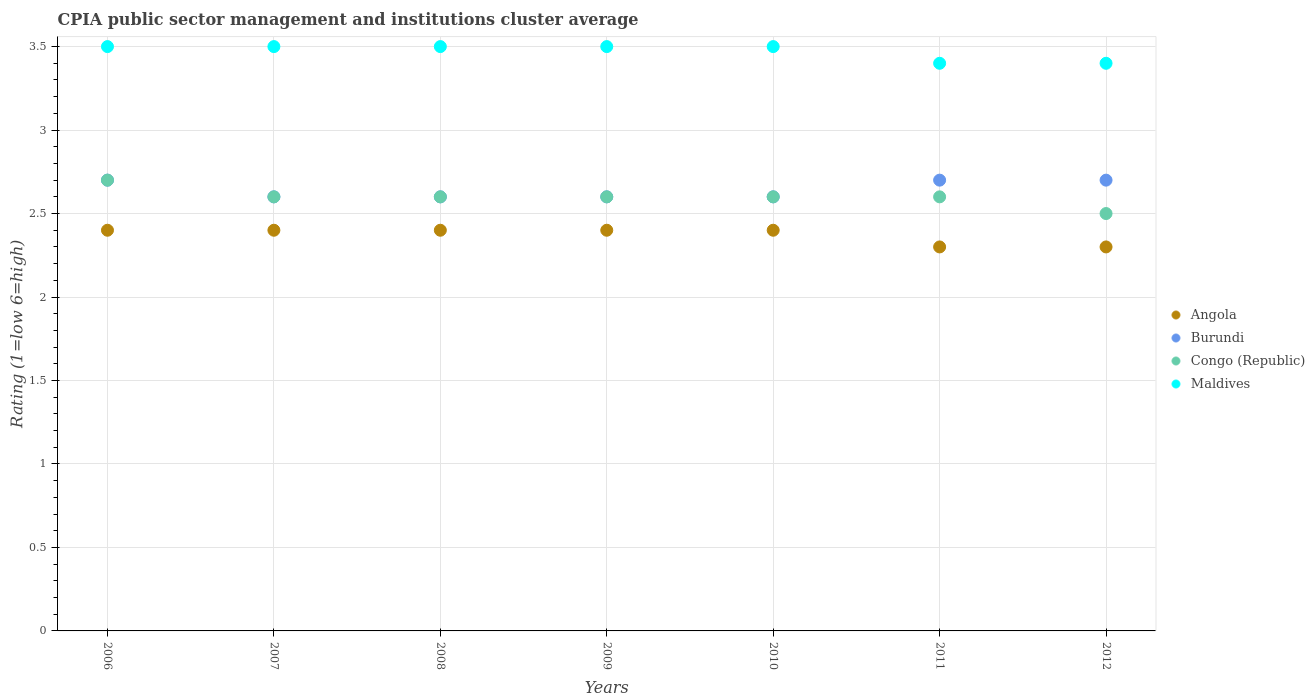Is the number of dotlines equal to the number of legend labels?
Give a very brief answer. Yes. What is the CPIA rating in Maldives in 2010?
Keep it short and to the point. 3.5. Across all years, what is the maximum CPIA rating in Angola?
Your response must be concise. 2.4. Across all years, what is the minimum CPIA rating in Angola?
Provide a succinct answer. 2.3. In which year was the CPIA rating in Burundi maximum?
Keep it short and to the point. 2006. What is the difference between the CPIA rating in Burundi in 2010 and that in 2011?
Your answer should be compact. -0.1. What is the difference between the CPIA rating in Maldives in 2009 and the CPIA rating in Angola in 2007?
Give a very brief answer. 1.1. What is the average CPIA rating in Maldives per year?
Provide a succinct answer. 3.47. In the year 2007, what is the difference between the CPIA rating in Burundi and CPIA rating in Maldives?
Give a very brief answer. -0.9. In how many years, is the CPIA rating in Angola greater than 1.5?
Your response must be concise. 7. What is the ratio of the CPIA rating in Angola in 2007 to that in 2009?
Your answer should be compact. 1. What is the difference between the highest and the lowest CPIA rating in Congo (Republic)?
Offer a terse response. 0.2. Is it the case that in every year, the sum of the CPIA rating in Congo (Republic) and CPIA rating in Burundi  is greater than the sum of CPIA rating in Maldives and CPIA rating in Angola?
Provide a short and direct response. No. Does the CPIA rating in Burundi monotonically increase over the years?
Ensure brevity in your answer.  No. Are the values on the major ticks of Y-axis written in scientific E-notation?
Make the answer very short. No. Does the graph contain grids?
Your answer should be very brief. Yes. What is the title of the graph?
Give a very brief answer. CPIA public sector management and institutions cluster average. What is the label or title of the Y-axis?
Provide a succinct answer. Rating (1=low 6=high). What is the Rating (1=low 6=high) of Angola in 2006?
Provide a short and direct response. 2.4. What is the Rating (1=low 6=high) of Burundi in 2006?
Your answer should be very brief. 2.7. What is the Rating (1=low 6=high) in Maldives in 2006?
Offer a very short reply. 3.5. What is the Rating (1=low 6=high) in Burundi in 2007?
Provide a short and direct response. 2.6. What is the Rating (1=low 6=high) in Congo (Republic) in 2007?
Make the answer very short. 2.6. What is the Rating (1=low 6=high) of Maldives in 2007?
Provide a short and direct response. 3.5. What is the Rating (1=low 6=high) of Angola in 2008?
Provide a succinct answer. 2.4. What is the Rating (1=low 6=high) in Burundi in 2008?
Ensure brevity in your answer.  2.6. What is the Rating (1=low 6=high) in Congo (Republic) in 2008?
Your answer should be very brief. 2.6. What is the Rating (1=low 6=high) in Maldives in 2008?
Provide a succinct answer. 3.5. What is the Rating (1=low 6=high) of Angola in 2010?
Ensure brevity in your answer.  2.4. What is the Rating (1=low 6=high) of Maldives in 2010?
Keep it short and to the point. 3.5. What is the Rating (1=low 6=high) of Burundi in 2011?
Provide a short and direct response. 2.7. What is the Rating (1=low 6=high) of Congo (Republic) in 2011?
Your response must be concise. 2.6. What is the Rating (1=low 6=high) in Angola in 2012?
Ensure brevity in your answer.  2.3. What is the Rating (1=low 6=high) in Congo (Republic) in 2012?
Your response must be concise. 2.5. Across all years, what is the maximum Rating (1=low 6=high) of Angola?
Ensure brevity in your answer.  2.4. Across all years, what is the maximum Rating (1=low 6=high) of Congo (Republic)?
Keep it short and to the point. 2.7. Across all years, what is the maximum Rating (1=low 6=high) in Maldives?
Your answer should be compact. 3.5. Across all years, what is the minimum Rating (1=low 6=high) of Congo (Republic)?
Offer a very short reply. 2.5. What is the total Rating (1=low 6=high) of Angola in the graph?
Ensure brevity in your answer.  16.6. What is the total Rating (1=low 6=high) in Burundi in the graph?
Your answer should be very brief. 18.5. What is the total Rating (1=low 6=high) in Congo (Republic) in the graph?
Your answer should be compact. 18.2. What is the total Rating (1=low 6=high) in Maldives in the graph?
Your answer should be very brief. 24.3. What is the difference between the Rating (1=low 6=high) of Burundi in 2006 and that in 2007?
Ensure brevity in your answer.  0.1. What is the difference between the Rating (1=low 6=high) of Angola in 2006 and that in 2008?
Make the answer very short. 0. What is the difference between the Rating (1=low 6=high) of Maldives in 2006 and that in 2008?
Offer a terse response. 0. What is the difference between the Rating (1=low 6=high) in Burundi in 2006 and that in 2009?
Your answer should be compact. 0.1. What is the difference between the Rating (1=low 6=high) of Maldives in 2006 and that in 2009?
Your response must be concise. 0. What is the difference between the Rating (1=low 6=high) of Burundi in 2006 and that in 2010?
Provide a short and direct response. 0.1. What is the difference between the Rating (1=low 6=high) of Angola in 2006 and that in 2011?
Your answer should be very brief. 0.1. What is the difference between the Rating (1=low 6=high) in Angola in 2006 and that in 2012?
Make the answer very short. 0.1. What is the difference between the Rating (1=low 6=high) of Congo (Republic) in 2006 and that in 2012?
Keep it short and to the point. 0.2. What is the difference between the Rating (1=low 6=high) in Maldives in 2006 and that in 2012?
Ensure brevity in your answer.  0.1. What is the difference between the Rating (1=low 6=high) of Angola in 2007 and that in 2008?
Offer a very short reply. 0. What is the difference between the Rating (1=low 6=high) of Burundi in 2007 and that in 2008?
Your answer should be very brief. 0. What is the difference between the Rating (1=low 6=high) of Congo (Republic) in 2007 and that in 2008?
Provide a short and direct response. 0. What is the difference between the Rating (1=low 6=high) of Burundi in 2007 and that in 2009?
Make the answer very short. 0. What is the difference between the Rating (1=low 6=high) in Burundi in 2007 and that in 2010?
Your answer should be compact. 0. What is the difference between the Rating (1=low 6=high) of Congo (Republic) in 2007 and that in 2010?
Provide a succinct answer. 0. What is the difference between the Rating (1=low 6=high) in Maldives in 2007 and that in 2010?
Offer a terse response. 0. What is the difference between the Rating (1=low 6=high) of Congo (Republic) in 2007 and that in 2011?
Your answer should be very brief. 0. What is the difference between the Rating (1=low 6=high) of Maldives in 2007 and that in 2011?
Your answer should be very brief. 0.1. What is the difference between the Rating (1=low 6=high) in Angola in 2007 and that in 2012?
Offer a very short reply. 0.1. What is the difference between the Rating (1=low 6=high) of Burundi in 2007 and that in 2012?
Your answer should be compact. -0.1. What is the difference between the Rating (1=low 6=high) in Congo (Republic) in 2008 and that in 2009?
Keep it short and to the point. 0. What is the difference between the Rating (1=low 6=high) in Angola in 2008 and that in 2010?
Ensure brevity in your answer.  0. What is the difference between the Rating (1=low 6=high) of Congo (Republic) in 2008 and that in 2010?
Make the answer very short. 0. What is the difference between the Rating (1=low 6=high) in Angola in 2008 and that in 2011?
Your answer should be compact. 0.1. What is the difference between the Rating (1=low 6=high) in Burundi in 2008 and that in 2012?
Keep it short and to the point. -0.1. What is the difference between the Rating (1=low 6=high) of Congo (Republic) in 2008 and that in 2012?
Your answer should be compact. 0.1. What is the difference between the Rating (1=low 6=high) of Angola in 2009 and that in 2011?
Provide a short and direct response. 0.1. What is the difference between the Rating (1=low 6=high) in Congo (Republic) in 2009 and that in 2011?
Keep it short and to the point. 0. What is the difference between the Rating (1=low 6=high) of Maldives in 2009 and that in 2011?
Give a very brief answer. 0.1. What is the difference between the Rating (1=low 6=high) of Angola in 2009 and that in 2012?
Provide a short and direct response. 0.1. What is the difference between the Rating (1=low 6=high) in Angola in 2010 and that in 2011?
Ensure brevity in your answer.  0.1. What is the difference between the Rating (1=low 6=high) of Burundi in 2010 and that in 2011?
Your answer should be very brief. -0.1. What is the difference between the Rating (1=low 6=high) of Congo (Republic) in 2010 and that in 2011?
Make the answer very short. 0. What is the difference between the Rating (1=low 6=high) of Maldives in 2010 and that in 2011?
Your response must be concise. 0.1. What is the difference between the Rating (1=low 6=high) of Angola in 2010 and that in 2012?
Give a very brief answer. 0.1. What is the difference between the Rating (1=low 6=high) in Burundi in 2010 and that in 2012?
Make the answer very short. -0.1. What is the difference between the Rating (1=low 6=high) in Congo (Republic) in 2010 and that in 2012?
Make the answer very short. 0.1. What is the difference between the Rating (1=low 6=high) of Angola in 2011 and that in 2012?
Provide a succinct answer. 0. What is the difference between the Rating (1=low 6=high) of Maldives in 2011 and that in 2012?
Your response must be concise. 0. What is the difference between the Rating (1=low 6=high) of Angola in 2006 and the Rating (1=low 6=high) of Congo (Republic) in 2007?
Give a very brief answer. -0.2. What is the difference between the Rating (1=low 6=high) of Burundi in 2006 and the Rating (1=low 6=high) of Maldives in 2007?
Your answer should be compact. -0.8. What is the difference between the Rating (1=low 6=high) of Congo (Republic) in 2006 and the Rating (1=low 6=high) of Maldives in 2007?
Keep it short and to the point. -0.8. What is the difference between the Rating (1=low 6=high) of Angola in 2006 and the Rating (1=low 6=high) of Maldives in 2008?
Your answer should be very brief. -1.1. What is the difference between the Rating (1=low 6=high) of Burundi in 2006 and the Rating (1=low 6=high) of Maldives in 2008?
Provide a short and direct response. -0.8. What is the difference between the Rating (1=low 6=high) in Angola in 2006 and the Rating (1=low 6=high) in Burundi in 2009?
Your response must be concise. -0.2. What is the difference between the Rating (1=low 6=high) in Burundi in 2006 and the Rating (1=low 6=high) in Congo (Republic) in 2009?
Make the answer very short. 0.1. What is the difference between the Rating (1=low 6=high) of Angola in 2006 and the Rating (1=low 6=high) of Burundi in 2010?
Give a very brief answer. -0.2. What is the difference between the Rating (1=low 6=high) in Burundi in 2006 and the Rating (1=low 6=high) in Maldives in 2010?
Your response must be concise. -0.8. What is the difference between the Rating (1=low 6=high) of Congo (Republic) in 2006 and the Rating (1=low 6=high) of Maldives in 2010?
Keep it short and to the point. -0.8. What is the difference between the Rating (1=low 6=high) of Angola in 2006 and the Rating (1=low 6=high) of Burundi in 2011?
Give a very brief answer. -0.3. What is the difference between the Rating (1=low 6=high) of Angola in 2006 and the Rating (1=low 6=high) of Congo (Republic) in 2011?
Offer a terse response. -0.2. What is the difference between the Rating (1=low 6=high) in Angola in 2006 and the Rating (1=low 6=high) in Maldives in 2011?
Your answer should be very brief. -1. What is the difference between the Rating (1=low 6=high) of Burundi in 2006 and the Rating (1=low 6=high) of Congo (Republic) in 2011?
Ensure brevity in your answer.  0.1. What is the difference between the Rating (1=low 6=high) in Angola in 2006 and the Rating (1=low 6=high) in Burundi in 2012?
Your answer should be very brief. -0.3. What is the difference between the Rating (1=low 6=high) in Angola in 2006 and the Rating (1=low 6=high) in Maldives in 2012?
Give a very brief answer. -1. What is the difference between the Rating (1=low 6=high) in Burundi in 2006 and the Rating (1=low 6=high) in Maldives in 2012?
Provide a succinct answer. -0.7. What is the difference between the Rating (1=low 6=high) of Burundi in 2007 and the Rating (1=low 6=high) of Congo (Republic) in 2008?
Offer a terse response. 0. What is the difference between the Rating (1=low 6=high) in Angola in 2007 and the Rating (1=low 6=high) in Maldives in 2009?
Make the answer very short. -1.1. What is the difference between the Rating (1=low 6=high) in Burundi in 2007 and the Rating (1=low 6=high) in Maldives in 2009?
Ensure brevity in your answer.  -0.9. What is the difference between the Rating (1=low 6=high) in Congo (Republic) in 2007 and the Rating (1=low 6=high) in Maldives in 2009?
Make the answer very short. -0.9. What is the difference between the Rating (1=low 6=high) in Angola in 2007 and the Rating (1=low 6=high) in Burundi in 2010?
Your answer should be very brief. -0.2. What is the difference between the Rating (1=low 6=high) of Angola in 2007 and the Rating (1=low 6=high) of Congo (Republic) in 2010?
Ensure brevity in your answer.  -0.2. What is the difference between the Rating (1=low 6=high) of Angola in 2007 and the Rating (1=low 6=high) of Congo (Republic) in 2011?
Provide a short and direct response. -0.2. What is the difference between the Rating (1=low 6=high) in Angola in 2007 and the Rating (1=low 6=high) in Maldives in 2011?
Give a very brief answer. -1. What is the difference between the Rating (1=low 6=high) of Burundi in 2007 and the Rating (1=low 6=high) of Maldives in 2011?
Provide a short and direct response. -0.8. What is the difference between the Rating (1=low 6=high) in Congo (Republic) in 2007 and the Rating (1=low 6=high) in Maldives in 2011?
Provide a short and direct response. -0.8. What is the difference between the Rating (1=low 6=high) in Angola in 2007 and the Rating (1=low 6=high) in Burundi in 2012?
Your answer should be very brief. -0.3. What is the difference between the Rating (1=low 6=high) of Angola in 2007 and the Rating (1=low 6=high) of Congo (Republic) in 2012?
Offer a very short reply. -0.1. What is the difference between the Rating (1=low 6=high) in Angola in 2007 and the Rating (1=low 6=high) in Maldives in 2012?
Your answer should be very brief. -1. What is the difference between the Rating (1=low 6=high) in Burundi in 2007 and the Rating (1=low 6=high) in Congo (Republic) in 2012?
Offer a very short reply. 0.1. What is the difference between the Rating (1=low 6=high) in Congo (Republic) in 2007 and the Rating (1=low 6=high) in Maldives in 2012?
Your answer should be compact. -0.8. What is the difference between the Rating (1=low 6=high) of Burundi in 2008 and the Rating (1=low 6=high) of Maldives in 2009?
Ensure brevity in your answer.  -0.9. What is the difference between the Rating (1=low 6=high) in Angola in 2008 and the Rating (1=low 6=high) in Congo (Republic) in 2010?
Ensure brevity in your answer.  -0.2. What is the difference between the Rating (1=low 6=high) in Angola in 2008 and the Rating (1=low 6=high) in Maldives in 2010?
Keep it short and to the point. -1.1. What is the difference between the Rating (1=low 6=high) of Burundi in 2008 and the Rating (1=low 6=high) of Maldives in 2010?
Your response must be concise. -0.9. What is the difference between the Rating (1=low 6=high) of Burundi in 2008 and the Rating (1=low 6=high) of Maldives in 2011?
Provide a succinct answer. -0.8. What is the difference between the Rating (1=low 6=high) of Congo (Republic) in 2008 and the Rating (1=low 6=high) of Maldives in 2011?
Offer a very short reply. -0.8. What is the difference between the Rating (1=low 6=high) of Angola in 2008 and the Rating (1=low 6=high) of Burundi in 2012?
Offer a terse response. -0.3. What is the difference between the Rating (1=low 6=high) in Angola in 2008 and the Rating (1=low 6=high) in Congo (Republic) in 2012?
Offer a terse response. -0.1. What is the difference between the Rating (1=low 6=high) in Burundi in 2008 and the Rating (1=low 6=high) in Maldives in 2012?
Your response must be concise. -0.8. What is the difference between the Rating (1=low 6=high) of Angola in 2009 and the Rating (1=low 6=high) of Congo (Republic) in 2010?
Keep it short and to the point. -0.2. What is the difference between the Rating (1=low 6=high) of Angola in 2009 and the Rating (1=low 6=high) of Maldives in 2010?
Give a very brief answer. -1.1. What is the difference between the Rating (1=low 6=high) in Burundi in 2009 and the Rating (1=low 6=high) in Congo (Republic) in 2010?
Provide a succinct answer. 0. What is the difference between the Rating (1=low 6=high) in Congo (Republic) in 2009 and the Rating (1=low 6=high) in Maldives in 2010?
Offer a very short reply. -0.9. What is the difference between the Rating (1=low 6=high) in Angola in 2009 and the Rating (1=low 6=high) in Burundi in 2011?
Your response must be concise. -0.3. What is the difference between the Rating (1=low 6=high) in Angola in 2009 and the Rating (1=low 6=high) in Congo (Republic) in 2011?
Provide a succinct answer. -0.2. What is the difference between the Rating (1=low 6=high) of Angola in 2009 and the Rating (1=low 6=high) of Maldives in 2011?
Your response must be concise. -1. What is the difference between the Rating (1=low 6=high) in Burundi in 2009 and the Rating (1=low 6=high) in Congo (Republic) in 2011?
Offer a very short reply. 0. What is the difference between the Rating (1=low 6=high) of Burundi in 2009 and the Rating (1=low 6=high) of Maldives in 2011?
Offer a terse response. -0.8. What is the difference between the Rating (1=low 6=high) in Congo (Republic) in 2009 and the Rating (1=low 6=high) in Maldives in 2011?
Provide a short and direct response. -0.8. What is the difference between the Rating (1=low 6=high) in Angola in 2009 and the Rating (1=low 6=high) in Burundi in 2012?
Provide a succinct answer. -0.3. What is the difference between the Rating (1=low 6=high) of Angola in 2009 and the Rating (1=low 6=high) of Congo (Republic) in 2012?
Offer a terse response. -0.1. What is the difference between the Rating (1=low 6=high) of Angola in 2009 and the Rating (1=low 6=high) of Maldives in 2012?
Make the answer very short. -1. What is the difference between the Rating (1=low 6=high) in Burundi in 2009 and the Rating (1=low 6=high) in Maldives in 2012?
Offer a very short reply. -0.8. What is the difference between the Rating (1=low 6=high) in Congo (Republic) in 2009 and the Rating (1=low 6=high) in Maldives in 2012?
Keep it short and to the point. -0.8. What is the difference between the Rating (1=low 6=high) in Angola in 2010 and the Rating (1=low 6=high) in Burundi in 2011?
Provide a short and direct response. -0.3. What is the difference between the Rating (1=low 6=high) of Burundi in 2010 and the Rating (1=low 6=high) of Maldives in 2011?
Offer a very short reply. -0.8. What is the difference between the Rating (1=low 6=high) of Congo (Republic) in 2010 and the Rating (1=low 6=high) of Maldives in 2011?
Provide a short and direct response. -0.8. What is the difference between the Rating (1=low 6=high) in Angola in 2010 and the Rating (1=low 6=high) in Burundi in 2012?
Offer a terse response. -0.3. What is the difference between the Rating (1=low 6=high) in Angola in 2010 and the Rating (1=low 6=high) in Congo (Republic) in 2012?
Your answer should be compact. -0.1. What is the difference between the Rating (1=low 6=high) in Congo (Republic) in 2010 and the Rating (1=low 6=high) in Maldives in 2012?
Your response must be concise. -0.8. What is the difference between the Rating (1=low 6=high) in Angola in 2011 and the Rating (1=low 6=high) in Maldives in 2012?
Offer a terse response. -1.1. What is the difference between the Rating (1=low 6=high) of Burundi in 2011 and the Rating (1=low 6=high) of Congo (Republic) in 2012?
Provide a short and direct response. 0.2. What is the difference between the Rating (1=low 6=high) in Burundi in 2011 and the Rating (1=low 6=high) in Maldives in 2012?
Give a very brief answer. -0.7. What is the difference between the Rating (1=low 6=high) in Congo (Republic) in 2011 and the Rating (1=low 6=high) in Maldives in 2012?
Provide a short and direct response. -0.8. What is the average Rating (1=low 6=high) of Angola per year?
Your answer should be compact. 2.37. What is the average Rating (1=low 6=high) in Burundi per year?
Provide a succinct answer. 2.64. What is the average Rating (1=low 6=high) of Congo (Republic) per year?
Keep it short and to the point. 2.6. What is the average Rating (1=low 6=high) of Maldives per year?
Provide a short and direct response. 3.47. In the year 2006, what is the difference between the Rating (1=low 6=high) in Burundi and Rating (1=low 6=high) in Congo (Republic)?
Your answer should be very brief. 0. In the year 2006, what is the difference between the Rating (1=low 6=high) in Burundi and Rating (1=low 6=high) in Maldives?
Your answer should be very brief. -0.8. In the year 2006, what is the difference between the Rating (1=low 6=high) in Congo (Republic) and Rating (1=low 6=high) in Maldives?
Provide a short and direct response. -0.8. In the year 2007, what is the difference between the Rating (1=low 6=high) in Angola and Rating (1=low 6=high) in Congo (Republic)?
Your response must be concise. -0.2. In the year 2007, what is the difference between the Rating (1=low 6=high) in Angola and Rating (1=low 6=high) in Maldives?
Your answer should be compact. -1.1. In the year 2007, what is the difference between the Rating (1=low 6=high) in Burundi and Rating (1=low 6=high) in Congo (Republic)?
Offer a very short reply. 0. In the year 2008, what is the difference between the Rating (1=low 6=high) in Angola and Rating (1=low 6=high) in Maldives?
Give a very brief answer. -1.1. In the year 2008, what is the difference between the Rating (1=low 6=high) of Congo (Republic) and Rating (1=low 6=high) of Maldives?
Offer a terse response. -0.9. In the year 2009, what is the difference between the Rating (1=low 6=high) in Angola and Rating (1=low 6=high) in Congo (Republic)?
Provide a short and direct response. -0.2. In the year 2009, what is the difference between the Rating (1=low 6=high) in Angola and Rating (1=low 6=high) in Maldives?
Your response must be concise. -1.1. In the year 2009, what is the difference between the Rating (1=low 6=high) of Burundi and Rating (1=low 6=high) of Maldives?
Offer a terse response. -0.9. In the year 2010, what is the difference between the Rating (1=low 6=high) of Angola and Rating (1=low 6=high) of Congo (Republic)?
Provide a succinct answer. -0.2. In the year 2010, what is the difference between the Rating (1=low 6=high) of Angola and Rating (1=low 6=high) of Maldives?
Your answer should be very brief. -1.1. In the year 2010, what is the difference between the Rating (1=low 6=high) in Burundi and Rating (1=low 6=high) in Congo (Republic)?
Ensure brevity in your answer.  0. In the year 2010, what is the difference between the Rating (1=low 6=high) of Congo (Republic) and Rating (1=low 6=high) of Maldives?
Provide a succinct answer. -0.9. In the year 2011, what is the difference between the Rating (1=low 6=high) of Angola and Rating (1=low 6=high) of Burundi?
Provide a succinct answer. -0.4. In the year 2011, what is the difference between the Rating (1=low 6=high) of Burundi and Rating (1=low 6=high) of Congo (Republic)?
Offer a terse response. 0.1. In the year 2011, what is the difference between the Rating (1=low 6=high) of Burundi and Rating (1=low 6=high) of Maldives?
Your answer should be very brief. -0.7. In the year 2012, what is the difference between the Rating (1=low 6=high) of Angola and Rating (1=low 6=high) of Congo (Republic)?
Provide a succinct answer. -0.2. In the year 2012, what is the difference between the Rating (1=low 6=high) in Angola and Rating (1=low 6=high) in Maldives?
Offer a terse response. -1.1. In the year 2012, what is the difference between the Rating (1=low 6=high) of Burundi and Rating (1=low 6=high) of Maldives?
Keep it short and to the point. -0.7. What is the ratio of the Rating (1=low 6=high) in Burundi in 2006 to that in 2007?
Offer a very short reply. 1.04. What is the ratio of the Rating (1=low 6=high) in Congo (Republic) in 2006 to that in 2007?
Ensure brevity in your answer.  1.04. What is the ratio of the Rating (1=low 6=high) of Congo (Republic) in 2006 to that in 2008?
Give a very brief answer. 1.04. What is the ratio of the Rating (1=low 6=high) in Maldives in 2006 to that in 2008?
Your answer should be compact. 1. What is the ratio of the Rating (1=low 6=high) in Burundi in 2006 to that in 2009?
Give a very brief answer. 1.04. What is the ratio of the Rating (1=low 6=high) in Congo (Republic) in 2006 to that in 2009?
Your response must be concise. 1.04. What is the ratio of the Rating (1=low 6=high) in Maldives in 2006 to that in 2009?
Provide a succinct answer. 1. What is the ratio of the Rating (1=low 6=high) in Congo (Republic) in 2006 to that in 2010?
Offer a terse response. 1.04. What is the ratio of the Rating (1=low 6=high) in Angola in 2006 to that in 2011?
Make the answer very short. 1.04. What is the ratio of the Rating (1=low 6=high) of Congo (Republic) in 2006 to that in 2011?
Your response must be concise. 1.04. What is the ratio of the Rating (1=low 6=high) of Maldives in 2006 to that in 2011?
Give a very brief answer. 1.03. What is the ratio of the Rating (1=low 6=high) of Angola in 2006 to that in 2012?
Offer a very short reply. 1.04. What is the ratio of the Rating (1=low 6=high) of Burundi in 2006 to that in 2012?
Offer a terse response. 1. What is the ratio of the Rating (1=low 6=high) in Congo (Republic) in 2006 to that in 2012?
Give a very brief answer. 1.08. What is the ratio of the Rating (1=low 6=high) in Maldives in 2006 to that in 2012?
Your response must be concise. 1.03. What is the ratio of the Rating (1=low 6=high) in Angola in 2007 to that in 2008?
Make the answer very short. 1. What is the ratio of the Rating (1=low 6=high) in Congo (Republic) in 2007 to that in 2008?
Provide a short and direct response. 1. What is the ratio of the Rating (1=low 6=high) of Maldives in 2007 to that in 2008?
Provide a short and direct response. 1. What is the ratio of the Rating (1=low 6=high) of Angola in 2007 to that in 2009?
Keep it short and to the point. 1. What is the ratio of the Rating (1=low 6=high) of Burundi in 2007 to that in 2009?
Provide a short and direct response. 1. What is the ratio of the Rating (1=low 6=high) in Angola in 2007 to that in 2010?
Provide a succinct answer. 1. What is the ratio of the Rating (1=low 6=high) of Congo (Republic) in 2007 to that in 2010?
Offer a terse response. 1. What is the ratio of the Rating (1=low 6=high) in Maldives in 2007 to that in 2010?
Give a very brief answer. 1. What is the ratio of the Rating (1=low 6=high) in Angola in 2007 to that in 2011?
Make the answer very short. 1.04. What is the ratio of the Rating (1=low 6=high) of Burundi in 2007 to that in 2011?
Your answer should be compact. 0.96. What is the ratio of the Rating (1=low 6=high) of Maldives in 2007 to that in 2011?
Offer a very short reply. 1.03. What is the ratio of the Rating (1=low 6=high) of Angola in 2007 to that in 2012?
Offer a very short reply. 1.04. What is the ratio of the Rating (1=low 6=high) of Congo (Republic) in 2007 to that in 2012?
Your answer should be compact. 1.04. What is the ratio of the Rating (1=low 6=high) in Maldives in 2007 to that in 2012?
Your answer should be compact. 1.03. What is the ratio of the Rating (1=low 6=high) of Angola in 2008 to that in 2009?
Your answer should be compact. 1. What is the ratio of the Rating (1=low 6=high) of Maldives in 2008 to that in 2009?
Offer a very short reply. 1. What is the ratio of the Rating (1=low 6=high) in Angola in 2008 to that in 2010?
Offer a very short reply. 1. What is the ratio of the Rating (1=low 6=high) in Burundi in 2008 to that in 2010?
Offer a very short reply. 1. What is the ratio of the Rating (1=low 6=high) of Congo (Republic) in 2008 to that in 2010?
Provide a short and direct response. 1. What is the ratio of the Rating (1=low 6=high) of Angola in 2008 to that in 2011?
Provide a succinct answer. 1.04. What is the ratio of the Rating (1=low 6=high) in Congo (Republic) in 2008 to that in 2011?
Offer a very short reply. 1. What is the ratio of the Rating (1=low 6=high) in Maldives in 2008 to that in 2011?
Offer a very short reply. 1.03. What is the ratio of the Rating (1=low 6=high) of Angola in 2008 to that in 2012?
Your answer should be compact. 1.04. What is the ratio of the Rating (1=low 6=high) in Maldives in 2008 to that in 2012?
Provide a succinct answer. 1.03. What is the ratio of the Rating (1=low 6=high) in Burundi in 2009 to that in 2010?
Your response must be concise. 1. What is the ratio of the Rating (1=low 6=high) of Congo (Republic) in 2009 to that in 2010?
Your response must be concise. 1. What is the ratio of the Rating (1=low 6=high) in Maldives in 2009 to that in 2010?
Give a very brief answer. 1. What is the ratio of the Rating (1=low 6=high) in Angola in 2009 to that in 2011?
Offer a very short reply. 1.04. What is the ratio of the Rating (1=low 6=high) in Maldives in 2009 to that in 2011?
Your answer should be compact. 1.03. What is the ratio of the Rating (1=low 6=high) of Angola in 2009 to that in 2012?
Your answer should be compact. 1.04. What is the ratio of the Rating (1=low 6=high) in Burundi in 2009 to that in 2012?
Your answer should be very brief. 0.96. What is the ratio of the Rating (1=low 6=high) of Congo (Republic) in 2009 to that in 2012?
Provide a short and direct response. 1.04. What is the ratio of the Rating (1=low 6=high) in Maldives in 2009 to that in 2012?
Provide a succinct answer. 1.03. What is the ratio of the Rating (1=low 6=high) of Angola in 2010 to that in 2011?
Your answer should be compact. 1.04. What is the ratio of the Rating (1=low 6=high) in Maldives in 2010 to that in 2011?
Your answer should be compact. 1.03. What is the ratio of the Rating (1=low 6=high) in Angola in 2010 to that in 2012?
Keep it short and to the point. 1.04. What is the ratio of the Rating (1=low 6=high) of Maldives in 2010 to that in 2012?
Offer a terse response. 1.03. What is the ratio of the Rating (1=low 6=high) in Burundi in 2011 to that in 2012?
Offer a very short reply. 1. What is the ratio of the Rating (1=low 6=high) of Congo (Republic) in 2011 to that in 2012?
Your answer should be very brief. 1.04. What is the difference between the highest and the second highest Rating (1=low 6=high) in Angola?
Keep it short and to the point. 0. What is the difference between the highest and the second highest Rating (1=low 6=high) in Congo (Republic)?
Your response must be concise. 0.1. What is the difference between the highest and the lowest Rating (1=low 6=high) in Burundi?
Offer a terse response. 0.1. 